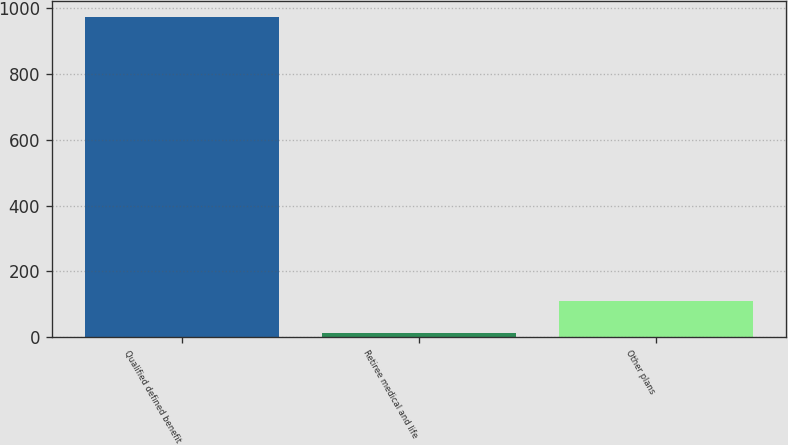Convert chart to OTSL. <chart><loc_0><loc_0><loc_500><loc_500><bar_chart><fcel>Qualified defined benefit<fcel>Retiree medical and life<fcel>Other plans<nl><fcel>974<fcel>12<fcel>108.2<nl></chart> 